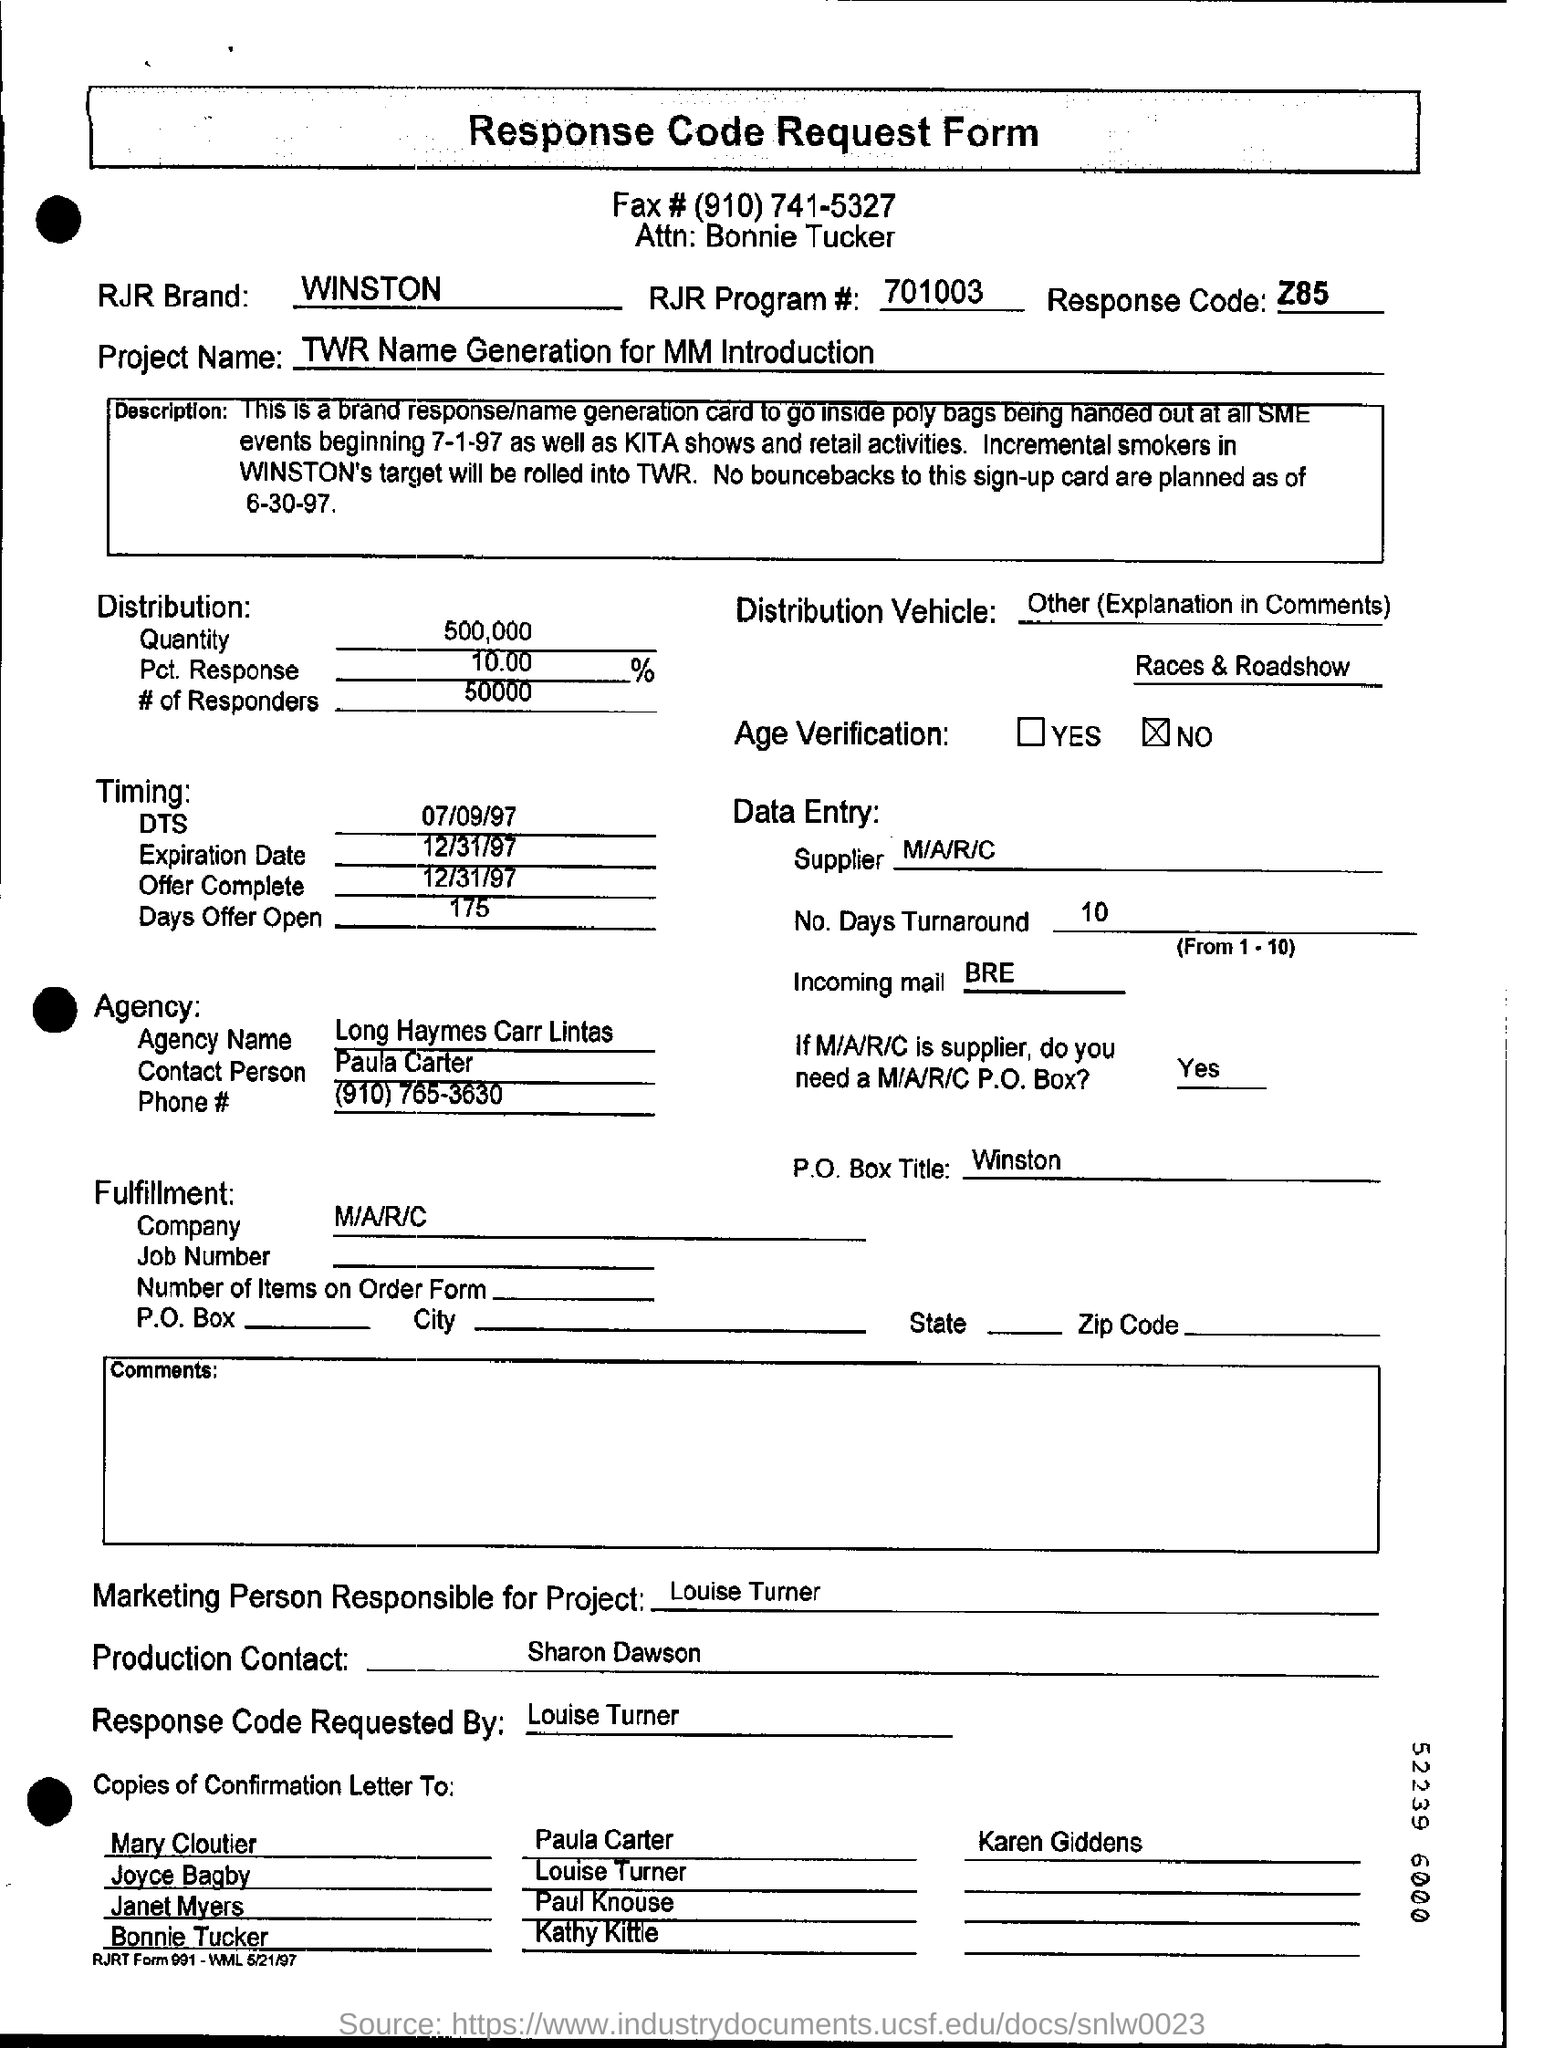Who will be the marketing person responsible for the project?
Offer a terse response. Louise turner. What is the quantity distribution mentioned in the request form?
Your answer should be very brief. 500,000. 